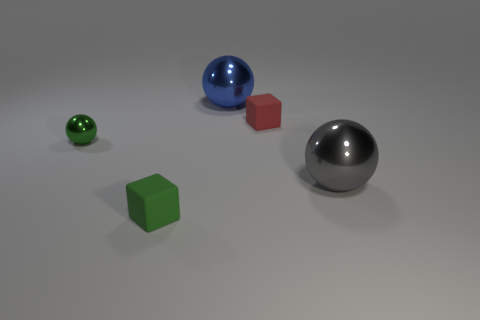The small rubber thing that is the same color as the tiny shiny object is what shape?
Your answer should be compact. Cube. How many green matte cubes have the same size as the red block?
Your response must be concise. 1. There is a metal thing to the right of the red object; is it the same size as the metallic object that is behind the tiny green shiny object?
Offer a terse response. Yes. What number of objects are small purple things or tiny matte cubes that are on the right side of the big blue metallic sphere?
Make the answer very short. 1. What is the color of the small shiny object?
Ensure brevity in your answer.  Green. What material is the tiny cube in front of the small rubber cube right of the green thing in front of the big gray object?
Give a very brief answer. Rubber. The green object that is the same material as the large blue object is what size?
Provide a succinct answer. Small. Is there a small sphere of the same color as the tiny shiny thing?
Offer a very short reply. No. Is the size of the green metallic object the same as the matte thing on the right side of the small green cube?
Your answer should be very brief. Yes. There is a rubber cube right of the big sphere behind the small green metallic ball; how many big gray metal spheres are right of it?
Offer a very short reply. 1. 